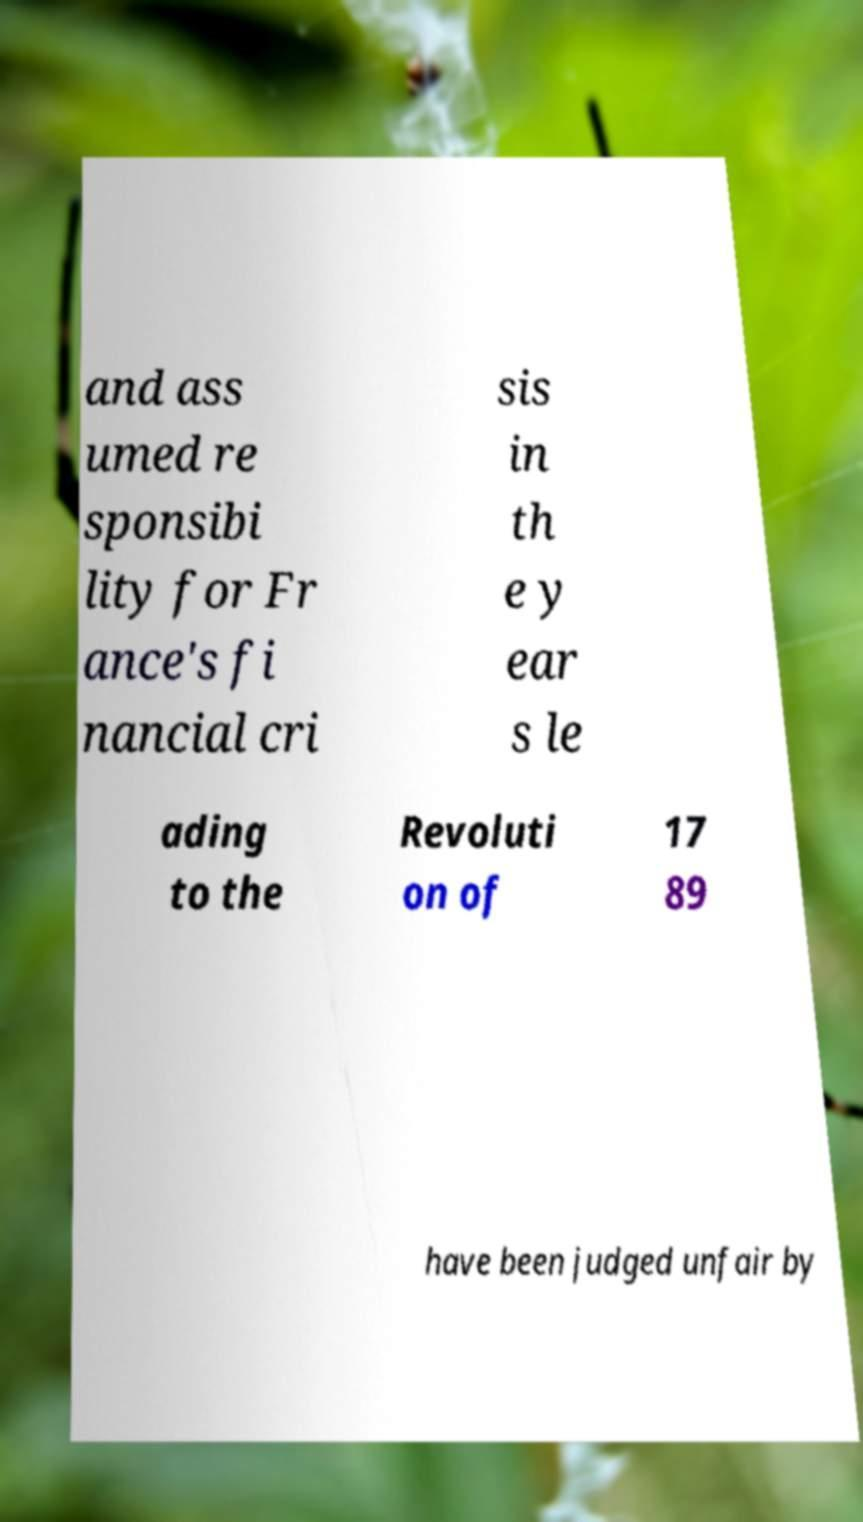What messages or text are displayed in this image? I need them in a readable, typed format. and ass umed re sponsibi lity for Fr ance's fi nancial cri sis in th e y ear s le ading to the Revoluti on of 17 89 have been judged unfair by 